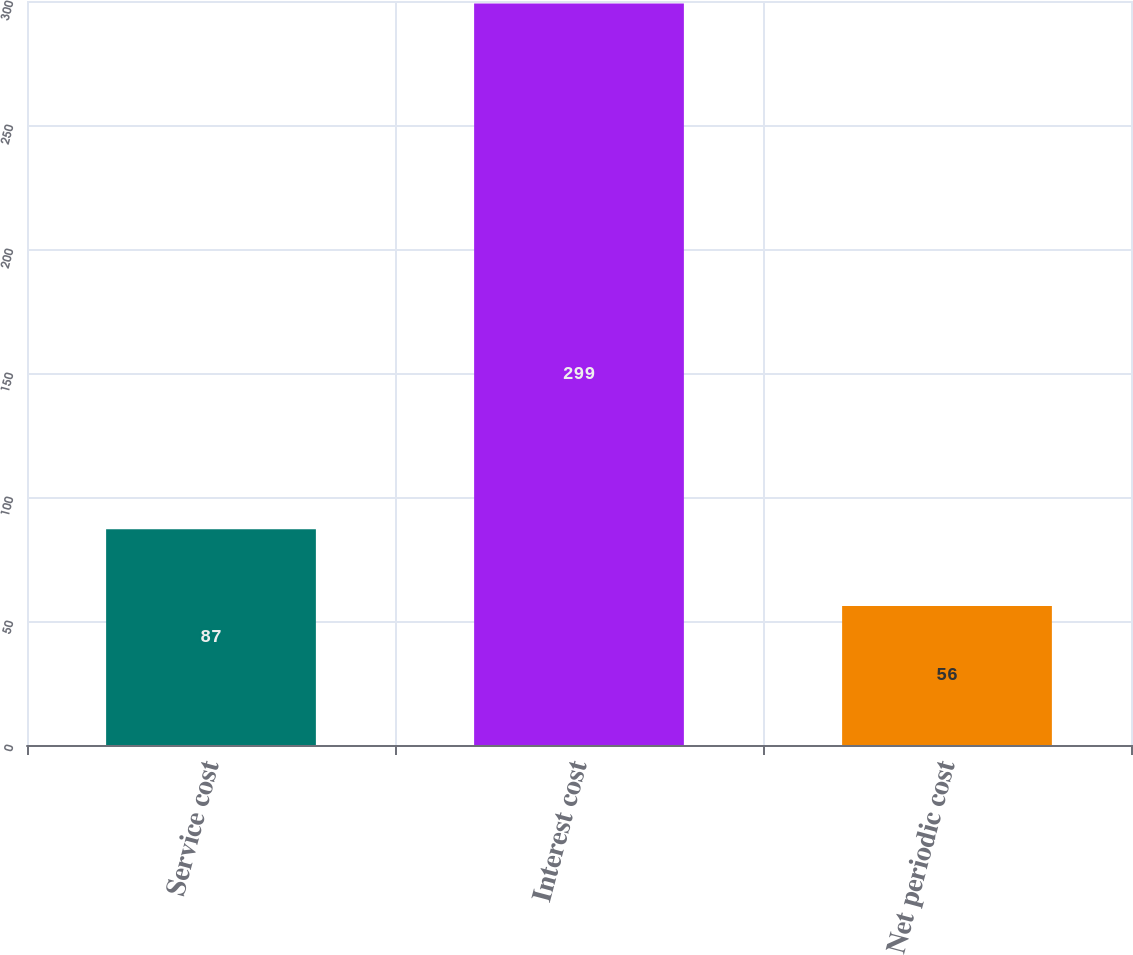Convert chart to OTSL. <chart><loc_0><loc_0><loc_500><loc_500><bar_chart><fcel>Service cost<fcel>Interest cost<fcel>Net periodic cost<nl><fcel>87<fcel>299<fcel>56<nl></chart> 